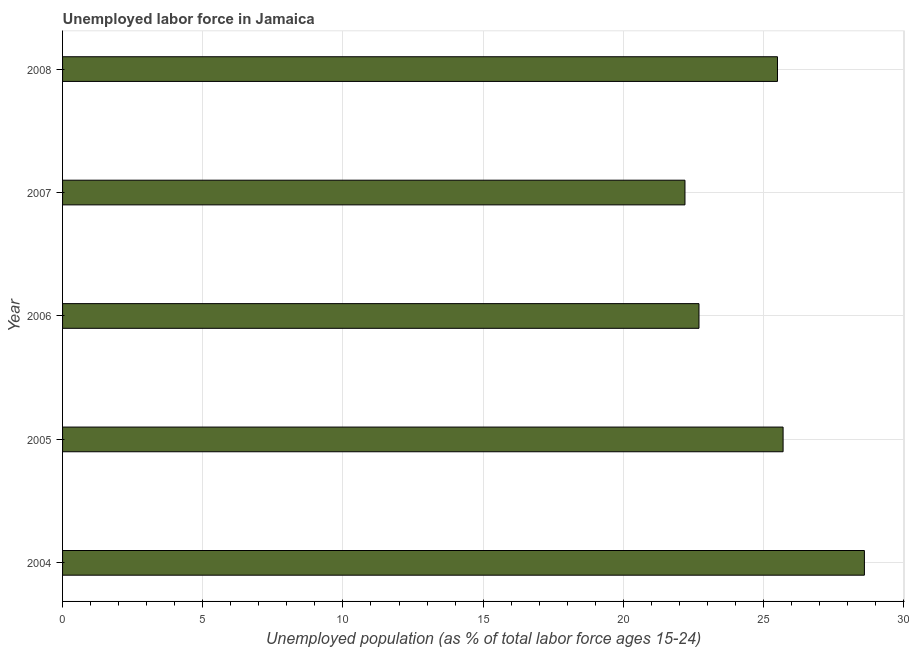Does the graph contain grids?
Your response must be concise. Yes. What is the title of the graph?
Ensure brevity in your answer.  Unemployed labor force in Jamaica. What is the label or title of the X-axis?
Provide a short and direct response. Unemployed population (as % of total labor force ages 15-24). What is the total unemployed youth population in 2004?
Provide a short and direct response. 28.6. Across all years, what is the maximum total unemployed youth population?
Offer a very short reply. 28.6. Across all years, what is the minimum total unemployed youth population?
Your response must be concise. 22.2. What is the sum of the total unemployed youth population?
Give a very brief answer. 124.7. What is the average total unemployed youth population per year?
Offer a very short reply. 24.94. Do a majority of the years between 2008 and 2006 (inclusive) have total unemployed youth population greater than 22 %?
Provide a short and direct response. Yes. Is the difference between the total unemployed youth population in 2006 and 2008 greater than the difference between any two years?
Your response must be concise. No. What is the difference between the highest and the second highest total unemployed youth population?
Provide a succinct answer. 2.9. Is the sum of the total unemployed youth population in 2004 and 2007 greater than the maximum total unemployed youth population across all years?
Ensure brevity in your answer.  Yes. What is the difference between the highest and the lowest total unemployed youth population?
Your response must be concise. 6.4. How many bars are there?
Give a very brief answer. 5. Are the values on the major ticks of X-axis written in scientific E-notation?
Ensure brevity in your answer.  No. What is the Unemployed population (as % of total labor force ages 15-24) of 2004?
Your answer should be very brief. 28.6. What is the Unemployed population (as % of total labor force ages 15-24) of 2005?
Keep it short and to the point. 25.7. What is the Unemployed population (as % of total labor force ages 15-24) of 2006?
Your response must be concise. 22.7. What is the Unemployed population (as % of total labor force ages 15-24) in 2007?
Your response must be concise. 22.2. What is the difference between the Unemployed population (as % of total labor force ages 15-24) in 2004 and 2006?
Your answer should be very brief. 5.9. What is the difference between the Unemployed population (as % of total labor force ages 15-24) in 2004 and 2007?
Make the answer very short. 6.4. What is the difference between the Unemployed population (as % of total labor force ages 15-24) in 2004 and 2008?
Ensure brevity in your answer.  3.1. What is the difference between the Unemployed population (as % of total labor force ages 15-24) in 2005 and 2006?
Offer a very short reply. 3. What is the difference between the Unemployed population (as % of total labor force ages 15-24) in 2006 and 2007?
Ensure brevity in your answer.  0.5. What is the difference between the Unemployed population (as % of total labor force ages 15-24) in 2006 and 2008?
Provide a short and direct response. -2.8. What is the ratio of the Unemployed population (as % of total labor force ages 15-24) in 2004 to that in 2005?
Your answer should be very brief. 1.11. What is the ratio of the Unemployed population (as % of total labor force ages 15-24) in 2004 to that in 2006?
Your answer should be compact. 1.26. What is the ratio of the Unemployed population (as % of total labor force ages 15-24) in 2004 to that in 2007?
Your answer should be very brief. 1.29. What is the ratio of the Unemployed population (as % of total labor force ages 15-24) in 2004 to that in 2008?
Ensure brevity in your answer.  1.12. What is the ratio of the Unemployed population (as % of total labor force ages 15-24) in 2005 to that in 2006?
Provide a short and direct response. 1.13. What is the ratio of the Unemployed population (as % of total labor force ages 15-24) in 2005 to that in 2007?
Keep it short and to the point. 1.16. What is the ratio of the Unemployed population (as % of total labor force ages 15-24) in 2005 to that in 2008?
Offer a very short reply. 1.01. What is the ratio of the Unemployed population (as % of total labor force ages 15-24) in 2006 to that in 2008?
Your answer should be very brief. 0.89. What is the ratio of the Unemployed population (as % of total labor force ages 15-24) in 2007 to that in 2008?
Give a very brief answer. 0.87. 